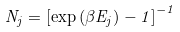Convert formula to latex. <formula><loc_0><loc_0><loc_500><loc_500>N _ { j } = \left [ \exp \left ( \beta E _ { j } \right ) - 1 \right ] ^ { - 1 }</formula> 